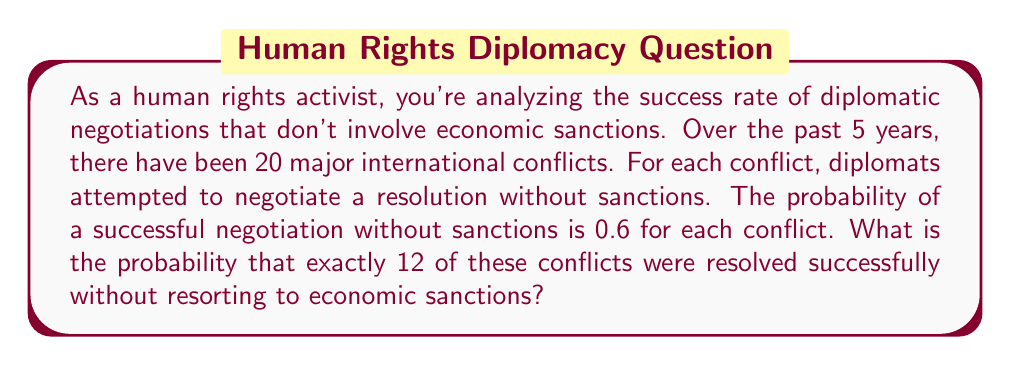Teach me how to tackle this problem. To solve this problem, we can use the binomial probability distribution. The binomial distribution is appropriate here because:

1. There is a fixed number of trials (20 conflicts).
2. Each trial has two possible outcomes (success or failure).
3. The probability of success is the same for each trial (0.6).
4. The trials are independent.

The binomial probability formula is:

$$ P(X = k) = \binom{n}{k} p^k (1-p)^{n-k} $$

Where:
- $n$ is the number of trials (20 conflicts)
- $k$ is the number of successes (12 successful negotiations)
- $p$ is the probability of success for each trial (0.6)

Let's solve step by step:

1. Calculate the binomial coefficient:
   $\binom{20}{12} = \frac{20!}{12!(20-12)!} = \frac{20!}{12!8!} = 125970$

2. Calculate $p^k$:
   $0.6^{12} \approx 0.0022$

3. Calculate $(1-p)^{n-k}$:
   $0.4^8 \approx 0.0066$

4. Multiply all parts together:
   $125970 \times 0.0022 \times 0.0066 \approx 0.1825$

Therefore, the probability of exactly 12 successful negotiations out of 20 conflicts is approximately 0.1825 or 18.25%.
Answer: $0.1825$ or $18.25\%$ 